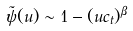Convert formula to latex. <formula><loc_0><loc_0><loc_500><loc_500>\tilde { \psi } ( u ) \sim 1 - ( u c _ { t } ) ^ { \beta }</formula> 